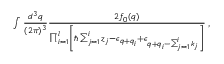<formula> <loc_0><loc_0><loc_500><loc_500>\begin{array} { r } { \int \frac { d ^ { 3 } q } { ( 2 \pi ) ^ { 3 } } \frac { 2 f _ { 0 } ( q ) } { \prod _ { i = 1 } ^ { l } \left [ \hbar { \sum } _ { j = 1 } ^ { i } z _ { j } - \epsilon _ { q + q _ { i } } + \epsilon _ { q + q _ { i } - \sum _ { j = 1 } ^ { i } k _ { j } } \right ] } \, , } \end{array}</formula> 